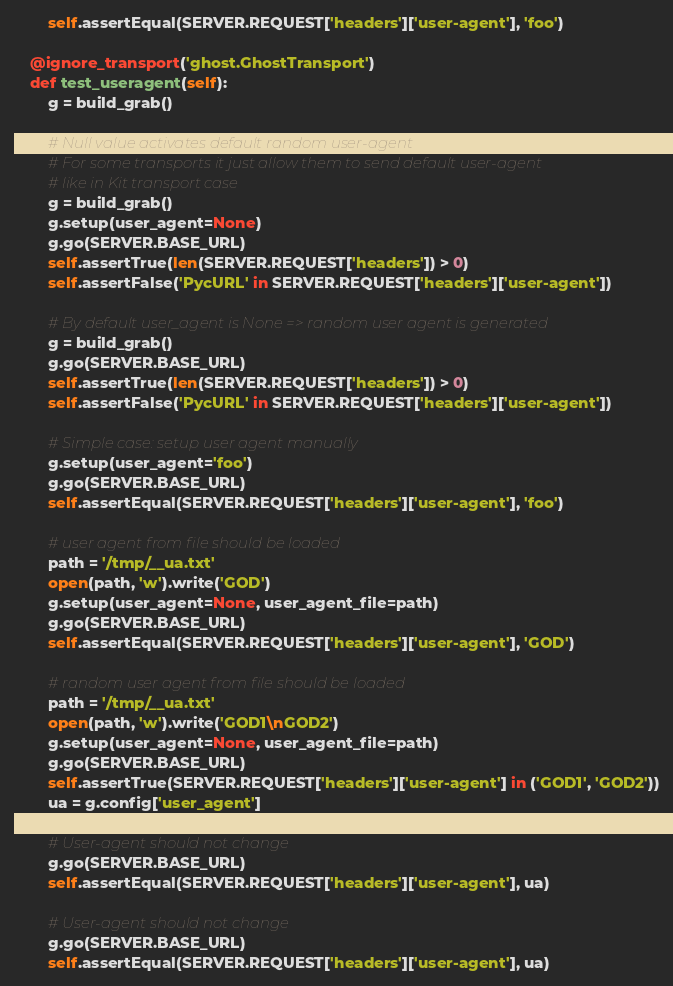<code> <loc_0><loc_0><loc_500><loc_500><_Python_>        self.assertEqual(SERVER.REQUEST['headers']['user-agent'], 'foo')

    @ignore_transport('ghost.GhostTransport')
    def test_useragent(self):
        g = build_grab()

        # Null value activates default random user-agent
        # For some transports it just allow them to send default user-agent
        # like in Kit transport case
        g = build_grab()
        g.setup(user_agent=None)
        g.go(SERVER.BASE_URL)
        self.assertTrue(len(SERVER.REQUEST['headers']) > 0)
        self.assertFalse('PycURL' in SERVER.REQUEST['headers']['user-agent'])

        # By default user_agent is None => random user agent is generated
        g = build_grab()
        g.go(SERVER.BASE_URL)
        self.assertTrue(len(SERVER.REQUEST['headers']) > 0)
        self.assertFalse('PycURL' in SERVER.REQUEST['headers']['user-agent'])

        # Simple case: setup user agent manually
        g.setup(user_agent='foo')
        g.go(SERVER.BASE_URL)
        self.assertEqual(SERVER.REQUEST['headers']['user-agent'], 'foo')
        
        # user agent from file should be loaded
        path = '/tmp/__ua.txt'
        open(path, 'w').write('GOD')
        g.setup(user_agent=None, user_agent_file=path)
        g.go(SERVER.BASE_URL)
        self.assertEqual(SERVER.REQUEST['headers']['user-agent'], 'GOD')

        # random user agent from file should be loaded
        path = '/tmp/__ua.txt'
        open(path, 'w').write('GOD1\nGOD2')
        g.setup(user_agent=None, user_agent_file=path)
        g.go(SERVER.BASE_URL)
        self.assertTrue(SERVER.REQUEST['headers']['user-agent'] in ('GOD1', 'GOD2'))
        ua = g.config['user_agent']

        # User-agent should not change
        g.go(SERVER.BASE_URL)
        self.assertEqual(SERVER.REQUEST['headers']['user-agent'], ua)

        # User-agent should not change
        g.go(SERVER.BASE_URL)
        self.assertEqual(SERVER.REQUEST['headers']['user-agent'], ua)
</code> 